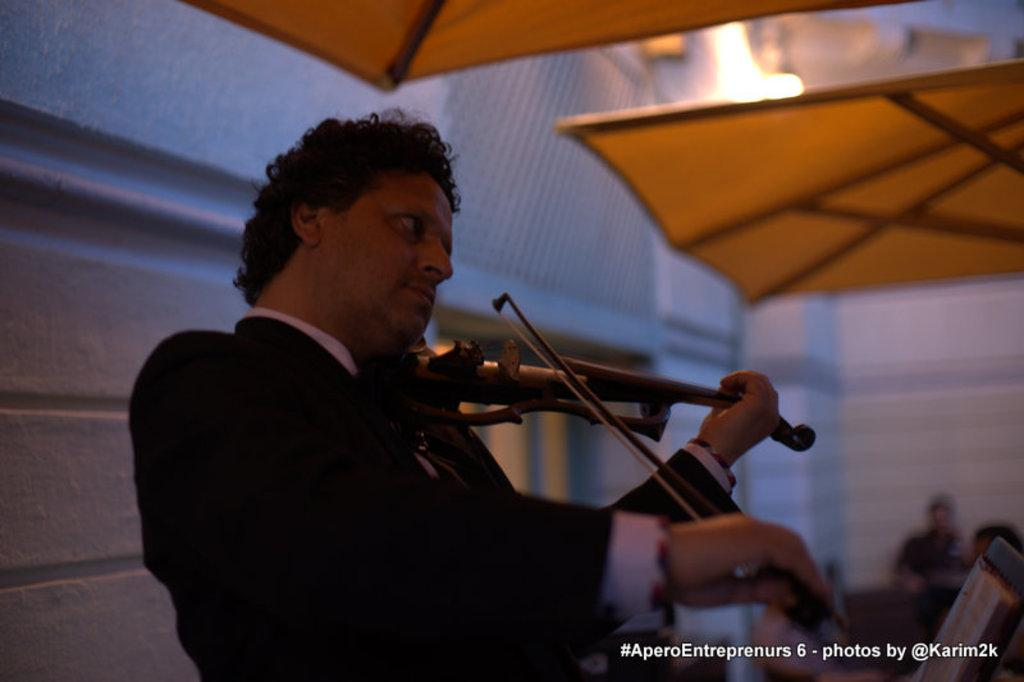What is the man in the image doing? The man is playing the violin in the image. What can be seen in the background of the image? There are people sitting, a wall, a window, and a sun shade in the background of the image. Can you describe the lighting in the image? There is light visible in the image. What type of fly is buzzing around the violin in the image? There is no fly present in the image; the man is playing the violin without any interruptions. What part of the dinner is being played by the man in the image? The image does not depict a dinner scene, and the man is playing the violin, not a part of a dinner. 